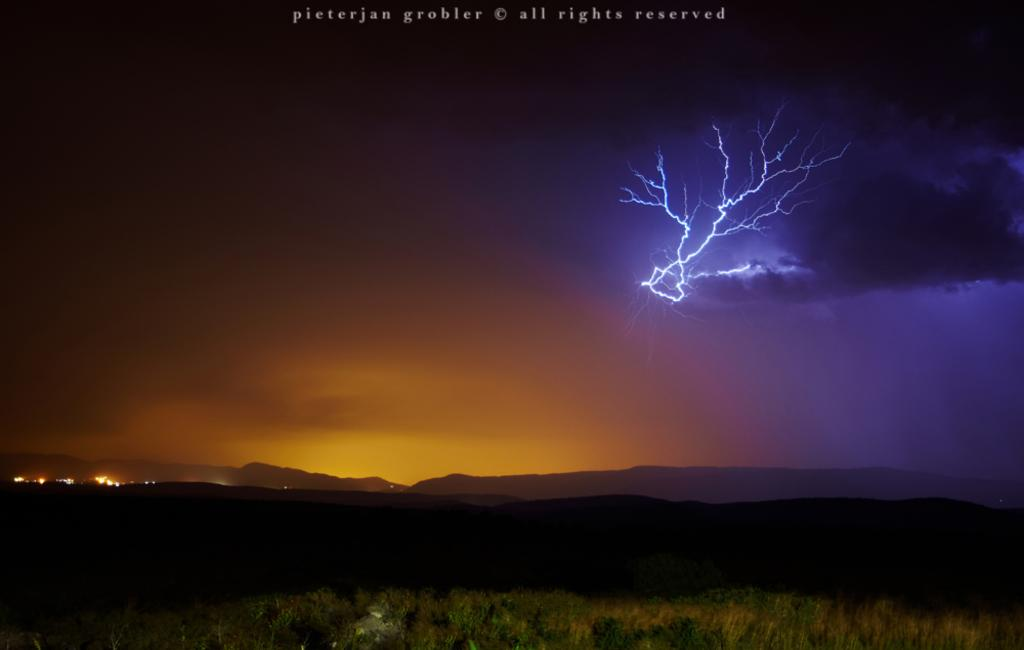What type of natural elements can be seen in the image? There are plants and mountains in the image. What artificial elements can be seen in the image? There are lights in the image. What is visible in the background of the image? The sky is visible in the background of the image. What can be observed in the sky? Clouds are present in the sky. What is the weight of the locket hanging from the plant in the image? There is no locket present in the image, and therefore no weight can be determined. 